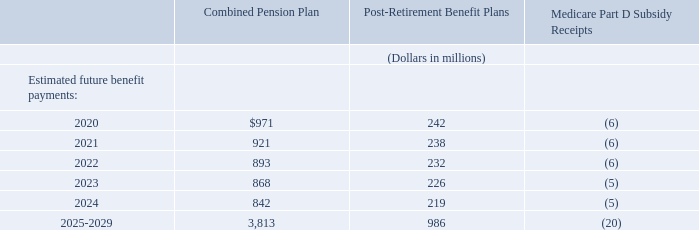Expected Cash Flows
The Combined Pension Plan payments, post-retirement health care benefit payments and premiums, and life insurance premium payments are either distributed from plan assets or paid by us. The estimated benefit payments provided below are based on actuarial assumptions using the demographics of the employee and retiree populations and have been reduced by estimated participant contributions.
Which payments are either distributed from plan assets or paid by the company? The combined pension plan payments, post-retirement health care benefit payments and premiums, and life insurance premium payments. What assumptions are the estimated benefit payments based on? Actuarial assumptions using the demographics of the employee and retiree populations and have been reduced by estimated participant contributions. What are the different periods highlighted in the table? 2020, 2021, 2022, 2023, 2024, 2025-2029. How many different period segments are highlighted in the table? 2020##2021##2022##2023##2024##2025-2029
Answer: 6. What is the change in combined pension plan in 2021 from 2020?
Answer scale should be: million. 921-971
Answer: -50. What is the percentage change in combined pension plan in 2021 from 2020?
Answer scale should be: percent. (921-971)/971
Answer: -5.15. 